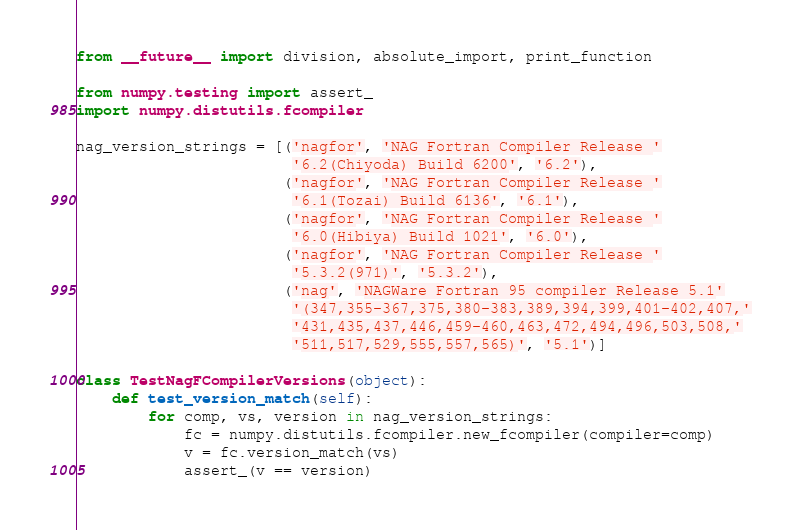<code> <loc_0><loc_0><loc_500><loc_500><_Python_>from __future__ import division, absolute_import, print_function

from numpy.testing import assert_
import numpy.distutils.fcompiler

nag_version_strings = [('nagfor', 'NAG Fortran Compiler Release '
                        '6.2(Chiyoda) Build 6200', '6.2'),
                       ('nagfor', 'NAG Fortran Compiler Release '
                        '6.1(Tozai) Build 6136', '6.1'),
                       ('nagfor', 'NAG Fortran Compiler Release '
                        '6.0(Hibiya) Build 1021', '6.0'),
                       ('nagfor', 'NAG Fortran Compiler Release '
                        '5.3.2(971)', '5.3.2'),
                       ('nag', 'NAGWare Fortran 95 compiler Release 5.1'
                        '(347,355-367,375,380-383,389,394,399,401-402,407,'
                        '431,435,437,446,459-460,463,472,494,496,503,508,'
                        '511,517,529,555,557,565)', '5.1')]

class TestNagFCompilerVersions(object):
    def test_version_match(self):
        for comp, vs, version in nag_version_strings:
            fc = numpy.distutils.fcompiler.new_fcompiler(compiler=comp)
            v = fc.version_match(vs)
            assert_(v == version)
</code> 